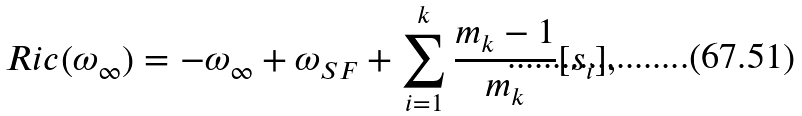<formula> <loc_0><loc_0><loc_500><loc_500>R i c ( \omega _ { \infty } ) = - \omega _ { \infty } + \omega _ { S F } + \sum _ { i = 1 } ^ { k } \frac { m _ { k } - 1 } { m _ { k } } [ s _ { i } ] ,</formula> 